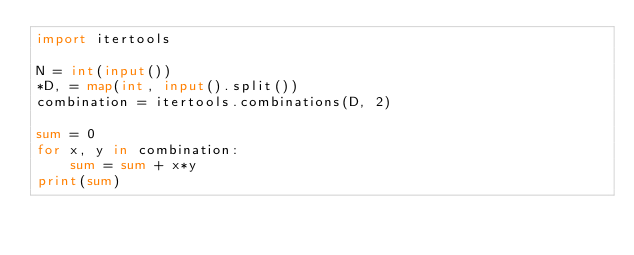<code> <loc_0><loc_0><loc_500><loc_500><_Python_>import itertools

N = int(input())
*D, = map(int, input().split())
combination = itertools.combinations(D, 2)

sum = 0
for x, y in combination:
    sum = sum + x*y
print(sum)
</code> 